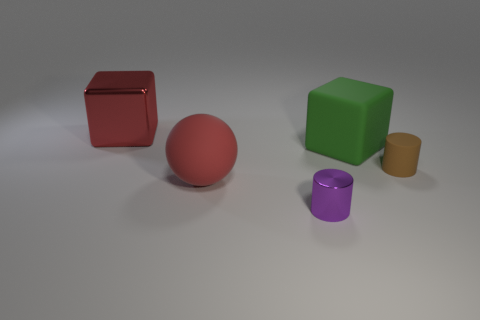Add 5 green matte objects. How many objects exist? 10 Subtract all blocks. How many objects are left? 3 Add 4 green rubber things. How many green rubber things exist? 5 Subtract 0 purple balls. How many objects are left? 5 Subtract all tiny metal objects. Subtract all red cylinders. How many objects are left? 4 Add 1 big red blocks. How many big red blocks are left? 2 